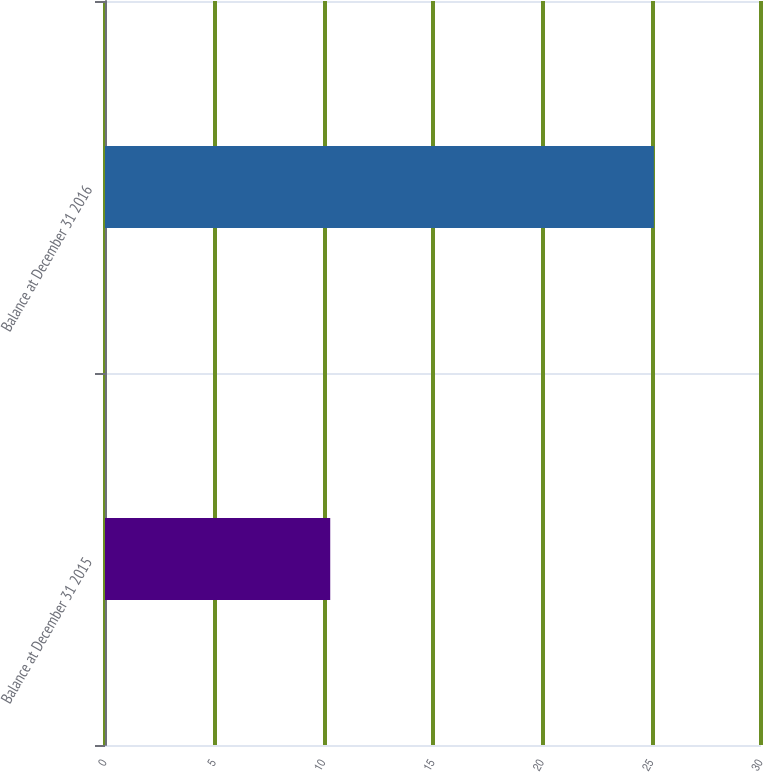Convert chart. <chart><loc_0><loc_0><loc_500><loc_500><bar_chart><fcel>Balance at December 31 2015<fcel>Balance at December 31 2016<nl><fcel>10.3<fcel>25.1<nl></chart> 